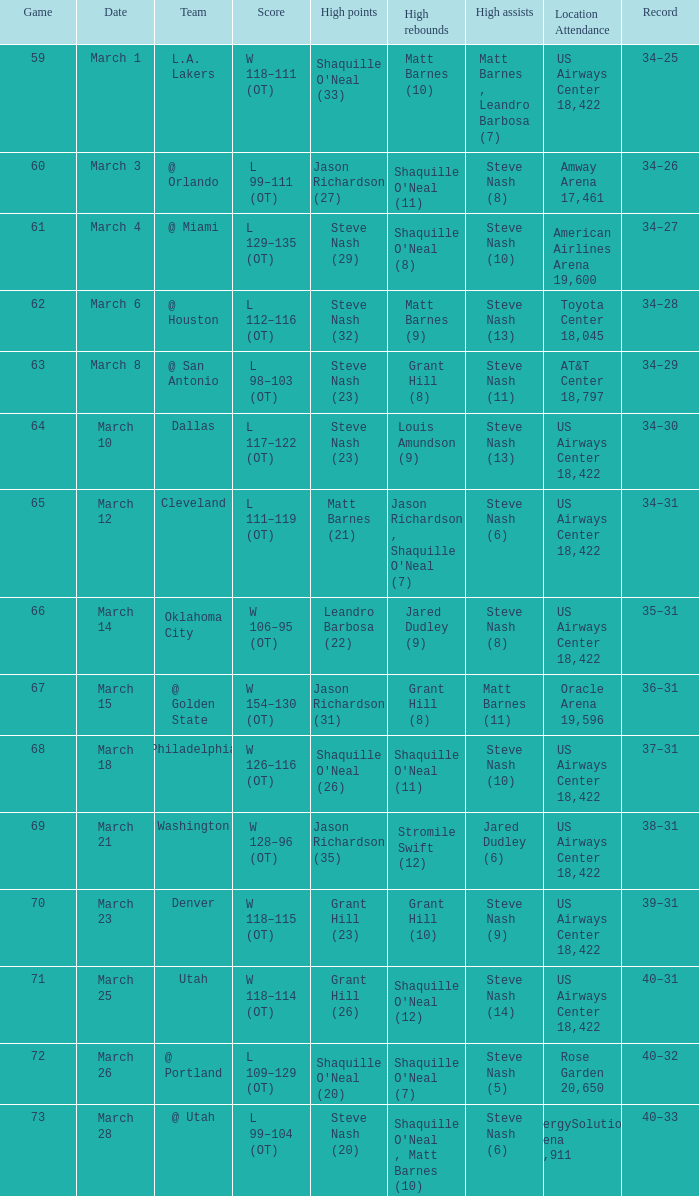Post the march 15 game, what was the group's record? 36–31. 